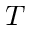Convert formula to latex. <formula><loc_0><loc_0><loc_500><loc_500>T</formula> 